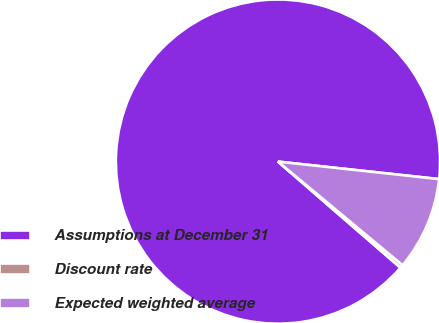<chart> <loc_0><loc_0><loc_500><loc_500><pie_chart><fcel>Assumptions at December 31<fcel>Discount rate<fcel>Expected weighted average<nl><fcel>90.36%<fcel>0.32%<fcel>9.32%<nl></chart> 